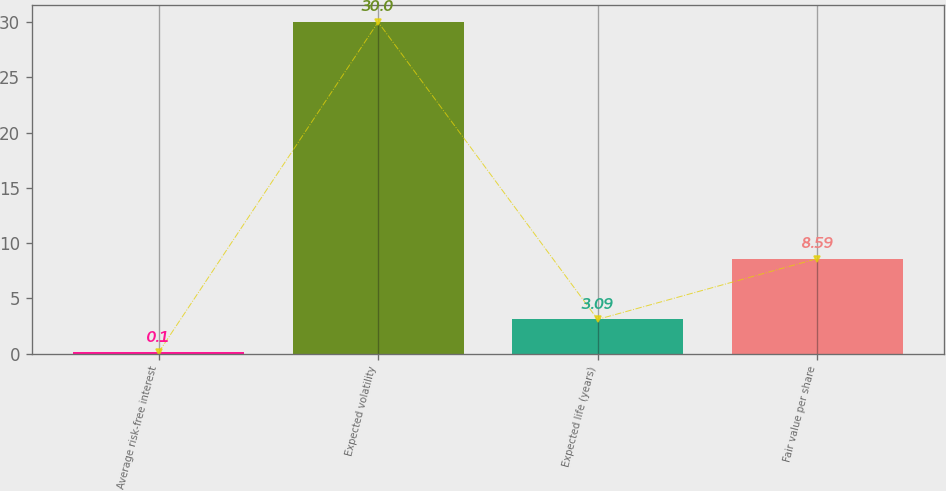Convert chart to OTSL. <chart><loc_0><loc_0><loc_500><loc_500><bar_chart><fcel>Average risk-free interest<fcel>Expected volatility<fcel>Expected life (years)<fcel>Fair value per share<nl><fcel>0.1<fcel>30<fcel>3.09<fcel>8.59<nl></chart> 